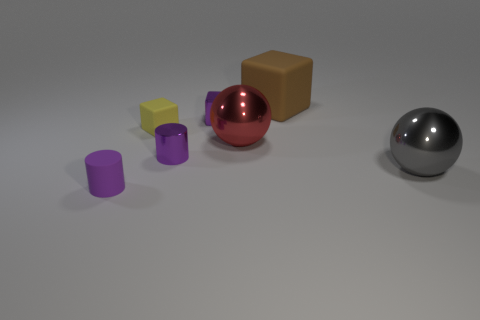Add 1 small gray shiny cylinders. How many objects exist? 8 Subtract all cubes. How many objects are left? 4 Subtract all tiny shiny blocks. Subtract all cyan metallic cylinders. How many objects are left? 6 Add 1 big cubes. How many big cubes are left? 2 Add 7 cyan matte cylinders. How many cyan matte cylinders exist? 7 Subtract 0 purple spheres. How many objects are left? 7 